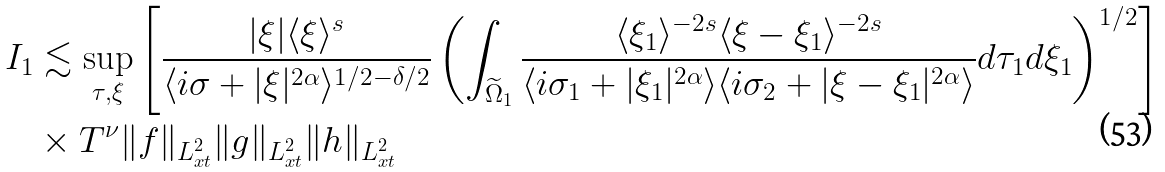Convert formula to latex. <formula><loc_0><loc_0><loc_500><loc_500>I _ { 1 } & \lesssim \sup _ { \tau , \xi } \left [ \frac { | \xi | \langle \xi \rangle ^ { s } } { \langle i \sigma + | \xi | ^ { 2 \alpha } \rangle ^ { 1 / 2 - \delta / 2 } } \left ( \int _ { \widetilde { \Omega } _ { 1 } } \frac { \langle \xi _ { 1 } \rangle ^ { - 2 s } \langle \xi - \xi _ { 1 } \rangle ^ { - 2 s } } { \langle i \sigma _ { 1 } + | \xi _ { 1 } | ^ { 2 \alpha } \rangle \langle i \sigma _ { 2 } + | \xi - \xi _ { 1 } | ^ { 2 \alpha } \rangle } d \tau _ { 1 } d \xi _ { 1 } \right ) ^ { 1 / 2 } \right ] \\ & \times T ^ { \nu } \| f \| _ { L ^ { 2 } _ { x t } } \| g \| _ { L ^ { 2 } _ { x t } } \| h \| _ { L ^ { 2 } _ { x t } }</formula> 